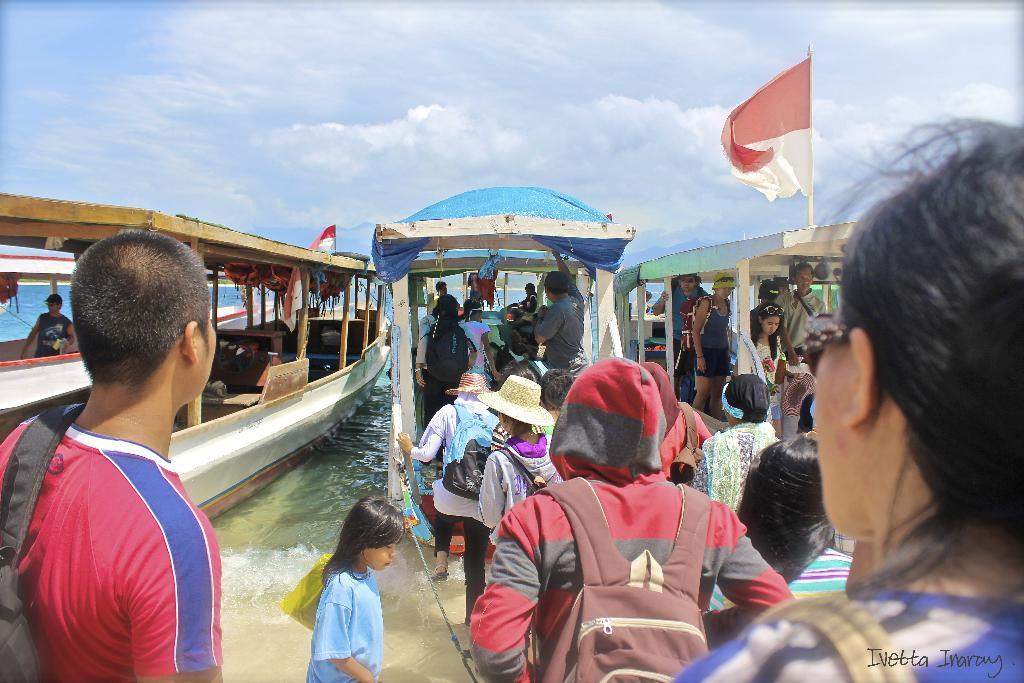Who is in the image? There are persons in the image. What are the persons doing in the image? The persons are getting into a boat. Where is the boat located? The boat is in the sea. What is visible in the sky in the image? The sky is visible in the image, and there are clouds in the sky. What type of property can be seen in the image? There is no property visible in the image; it features persons getting into a boat in the sea. How many trees are present in the image? There are no trees present in the image; it features persons getting into a boat in the sea. 